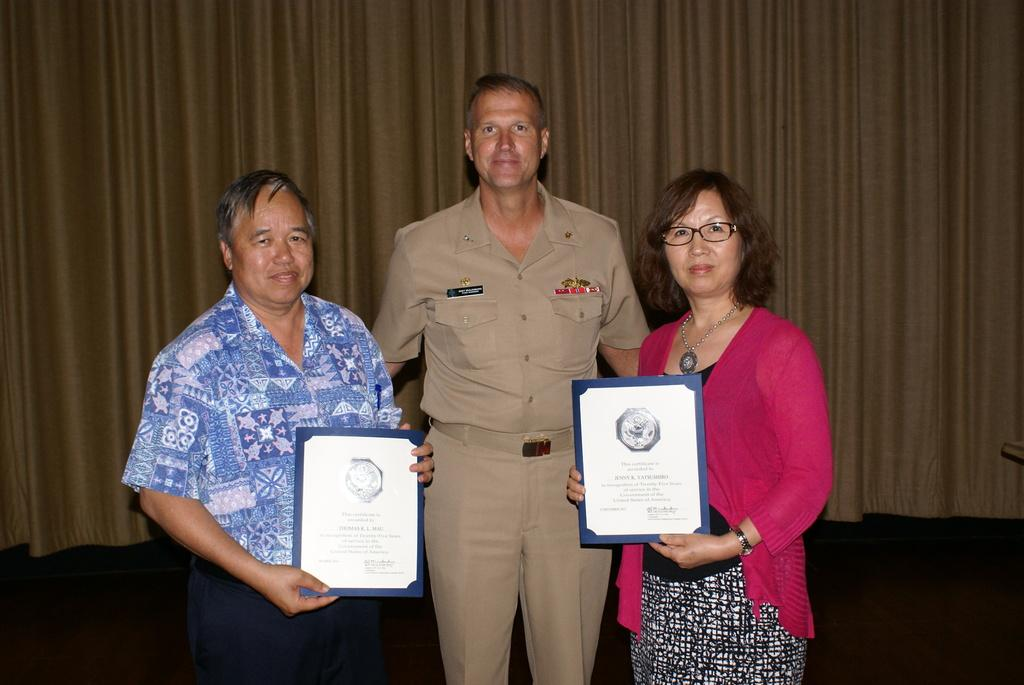How many people are present in the image? There are three persons standing in the image. What are two of the persons holding? Two of the persons are holding certificates. What can be seen in the background of the image? There is a curtain in the background of the image. What type of sheep can be seen grazing in the background of the image? There are no sheep present in the image; it only features three persons and a curtain in the background. 